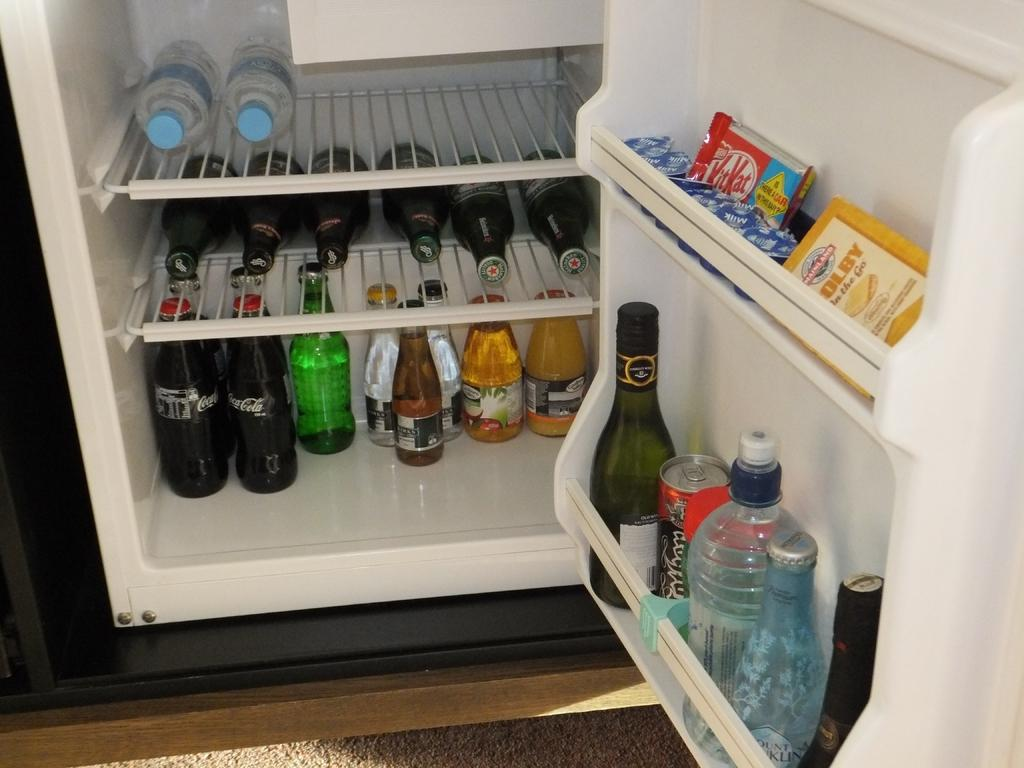What is the location from where the image was taken? The image is taken from inside a fridge. How many bottles can be seen in the fridge? There are two bottles in the fridge. What type of bottles are present in the fridge? The bottles are alcohol bottles. What other items can be seen in the fridge? There are aerated beverages, chocolates, and cheese in the fridge. What is the color of the fridge? The fridge is white in color. Can you see a grape being eaten by a self in the image? There is no grape or self present in the image; it is taken inside a fridge and shows various items stored there. Is there a fireman in the fridge in the image? There is no fireman present in the image; it is taken inside a fridge and shows various items stored there. 